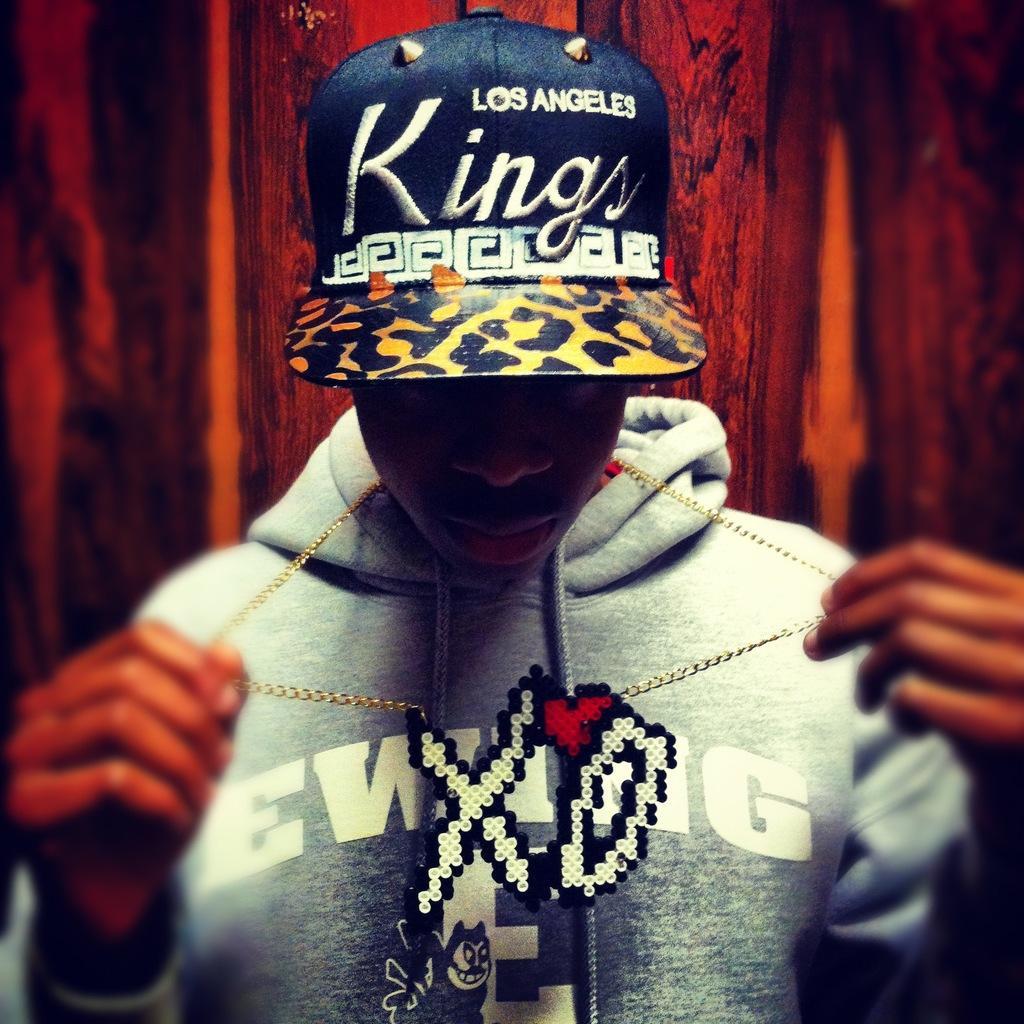Could you give a brief overview of what you see in this image? A boy is here, he wore a sweater, black color cap. 